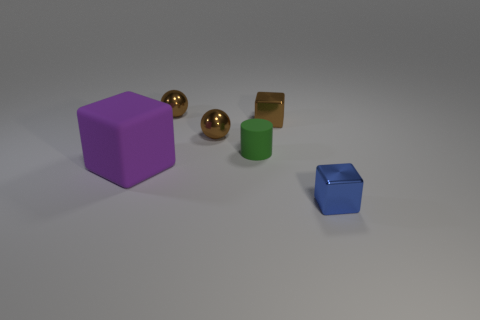How many other objects are there of the same size as the purple matte block? 0 